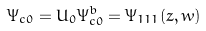<formula> <loc_0><loc_0><loc_500><loc_500>\Psi _ { c 0 } = U _ { 0 } \Psi ^ { b } _ { c 0 } = \Psi _ { 1 1 1 } ( z , w )</formula> 